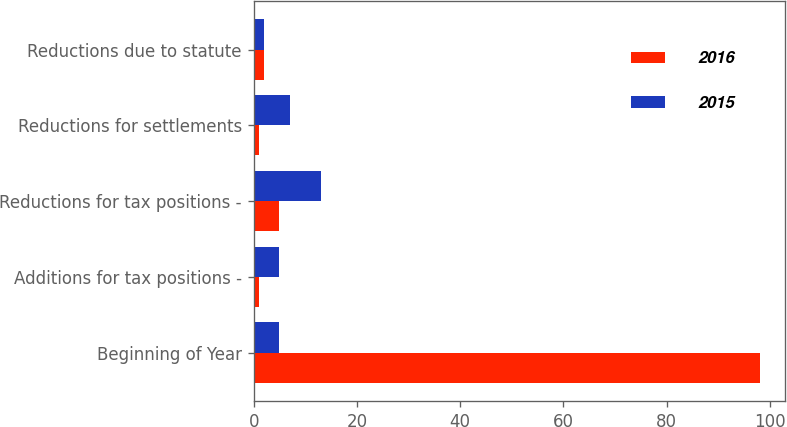<chart> <loc_0><loc_0><loc_500><loc_500><stacked_bar_chart><ecel><fcel>Beginning of Year<fcel>Additions for tax positions -<fcel>Reductions for tax positions -<fcel>Reductions for settlements<fcel>Reductions due to statute<nl><fcel>2016<fcel>98<fcel>1<fcel>5<fcel>1<fcel>2<nl><fcel>2015<fcel>5<fcel>5<fcel>13<fcel>7<fcel>2<nl></chart> 